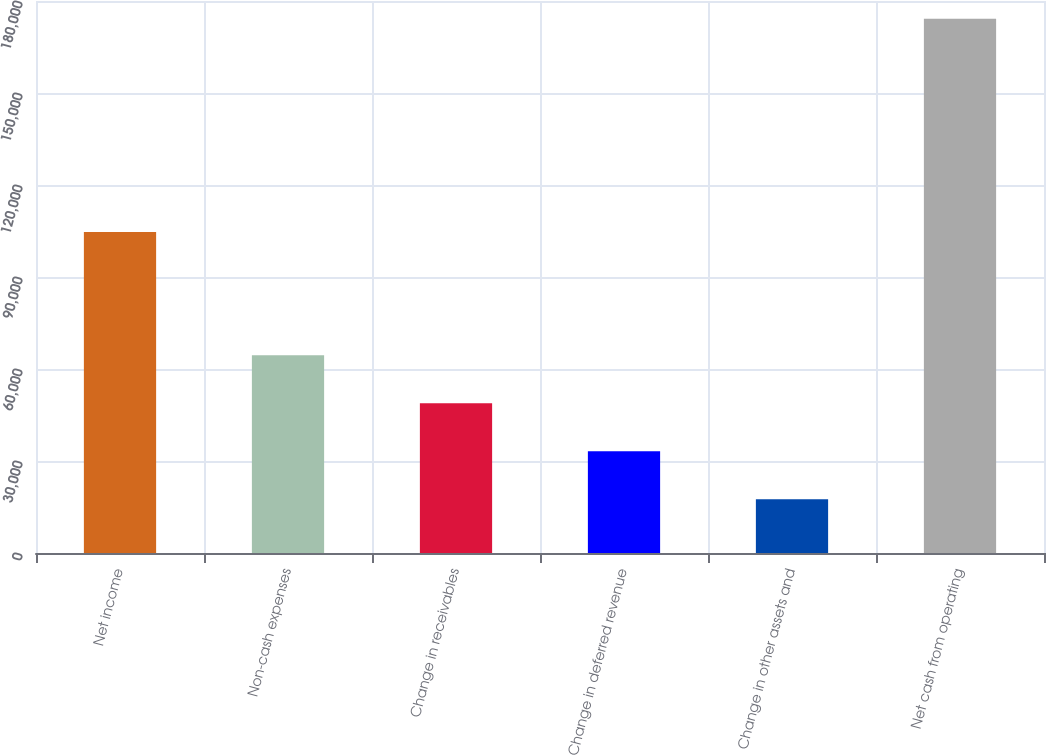<chart> <loc_0><loc_0><loc_500><loc_500><bar_chart><fcel>Net income<fcel>Non-cash expenses<fcel>Change in receivables<fcel>Change in deferred revenue<fcel>Change in other assets and<fcel>Net cash from operating<nl><fcel>104681<fcel>64520.6<fcel>48845.4<fcel>33170.2<fcel>17495<fcel>174247<nl></chart> 